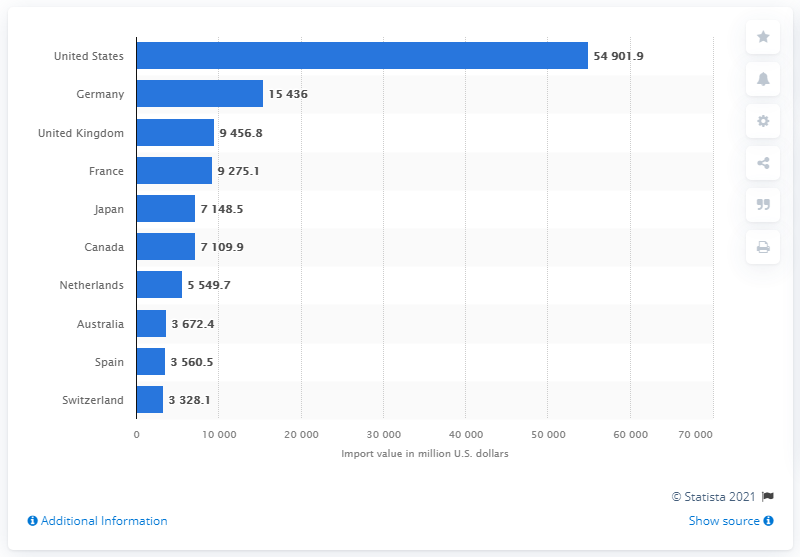Specify some key components in this picture. In 2019, Germany imported a significant amount of furniture into the United States, totaling 15,436 units. In 2019, the value of furniture imported from other countries into the United States was approximately 54,901.9 million dollars. 